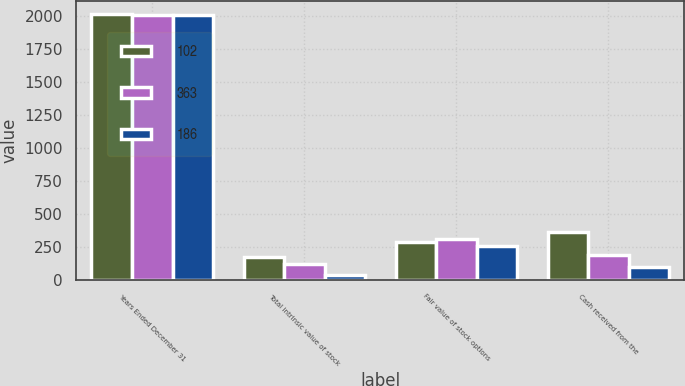<chart> <loc_0><loc_0><loc_500><loc_500><stacked_bar_chart><ecel><fcel>Years Ended December 31<fcel>Total intrinsic value of stock<fcel>Fair value of stock options<fcel>Cash received from the<nl><fcel>102<fcel>2010<fcel>177<fcel>290<fcel>363<nl><fcel>363<fcel>2009<fcel>119<fcel>311<fcel>186<nl><fcel>186<fcel>2008<fcel>40<fcel>259<fcel>102<nl></chart> 